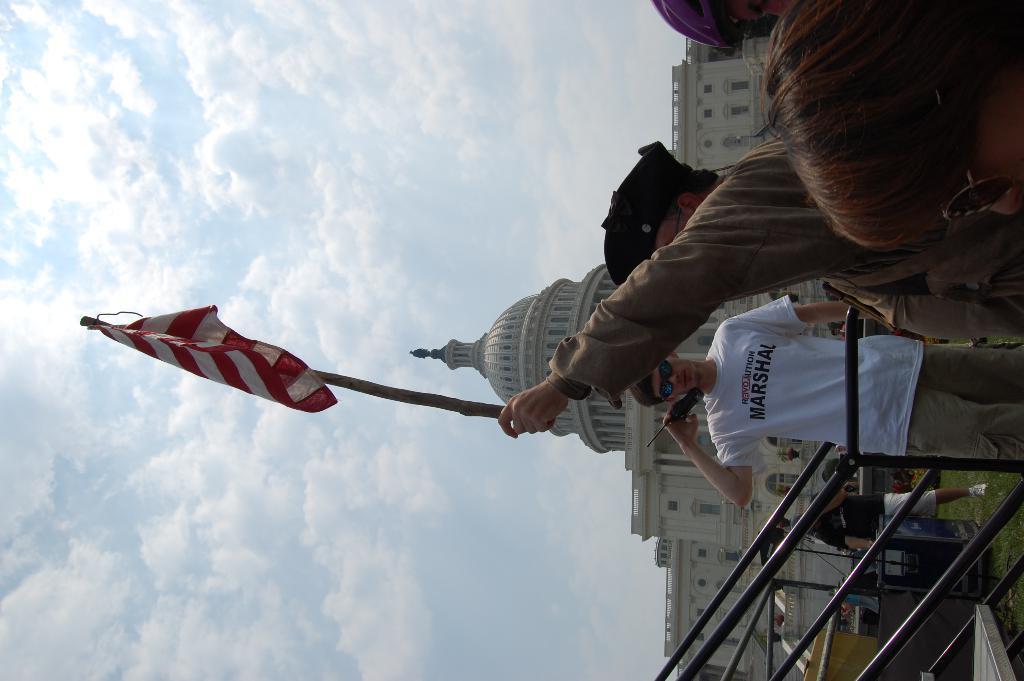Can you describe this image briefly? This picture shows few people standing and we see a man wore a cap on his head and holding a flag in his hand and we see another man wore sunglasses on his face and he is holding a walkie-talkie in his hand and we see a building and a cloudy Sky and we see grass on the ground and stairs. 